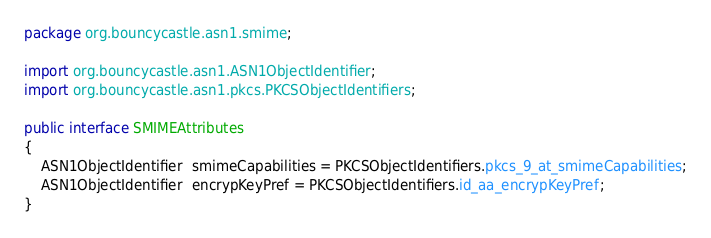<code> <loc_0><loc_0><loc_500><loc_500><_Java_>package org.bouncycastle.asn1.smime;

import org.bouncycastle.asn1.ASN1ObjectIdentifier;
import org.bouncycastle.asn1.pkcs.PKCSObjectIdentifiers;

public interface SMIMEAttributes
{
    ASN1ObjectIdentifier  smimeCapabilities = PKCSObjectIdentifiers.pkcs_9_at_smimeCapabilities;
    ASN1ObjectIdentifier  encrypKeyPref = PKCSObjectIdentifiers.id_aa_encrypKeyPref;
}
</code> 